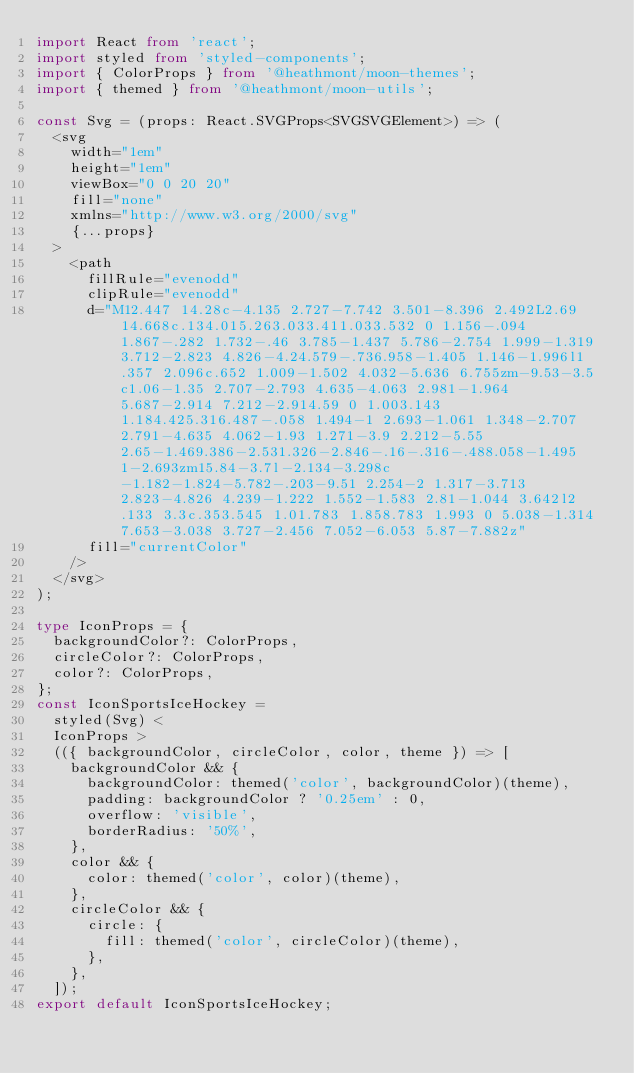<code> <loc_0><loc_0><loc_500><loc_500><_TypeScript_>import React from 'react';
import styled from 'styled-components';
import { ColorProps } from '@heathmont/moon-themes';
import { themed } from '@heathmont/moon-utils';

const Svg = (props: React.SVGProps<SVGSVGElement>) => (
  <svg
    width="1em"
    height="1em"
    viewBox="0 0 20 20"
    fill="none"
    xmlns="http://www.w3.org/2000/svg"
    {...props}
  >
    <path
      fillRule="evenodd"
      clipRule="evenodd"
      d="M12.447 14.28c-4.135 2.727-7.742 3.501-8.396 2.492L2.69 14.668c.134.015.263.033.411.033.532 0 1.156-.094 1.867-.282 1.732-.46 3.785-1.437 5.786-2.754 1.999-1.319 3.712-2.823 4.826-4.24.579-.736.958-1.405 1.146-1.996l1.357 2.096c.652 1.009-1.502 4.032-5.636 6.755zm-9.53-3.5c1.06-1.35 2.707-2.793 4.635-4.063 2.981-1.964 5.687-2.914 7.212-2.914.59 0 1.003.143 1.184.425.316.487-.058 1.494-1 2.693-1.061 1.348-2.707 2.791-4.635 4.062-1.93 1.271-3.9 2.212-5.55 2.65-1.469.386-2.531.326-2.846-.16-.316-.488.058-1.495 1-2.693zm15.84-3.7l-2.134-3.298c-1.182-1.824-5.782-.203-9.51 2.254-2 1.317-3.713 2.823-4.826 4.239-1.222 1.552-1.583 2.81-1.044 3.642l2.133 3.3c.353.545 1.01.783 1.858.783 1.993 0 5.038-1.314 7.653-3.038 3.727-2.456 7.052-6.053 5.87-7.882z"
      fill="currentColor"
    />
  </svg>
);

type IconProps = {
  backgroundColor?: ColorProps,
  circleColor?: ColorProps,
  color?: ColorProps,
};
const IconSportsIceHockey =
  styled(Svg) <
  IconProps >
  (({ backgroundColor, circleColor, color, theme }) => [
    backgroundColor && {
      backgroundColor: themed('color', backgroundColor)(theme),
      padding: backgroundColor ? '0.25em' : 0,
      overflow: 'visible',
      borderRadius: '50%',
    },
    color && {
      color: themed('color', color)(theme),
    },
    circleColor && {
      circle: {
        fill: themed('color', circleColor)(theme),
      },
    },
  ]);
export default IconSportsIceHockey;
</code> 